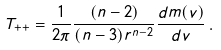Convert formula to latex. <formula><loc_0><loc_0><loc_500><loc_500>T _ { + + } = \frac { 1 } { 2 \pi } \frac { ( n - 2 ) } { ( n - 3 ) r ^ { n - 2 } } \frac { d m ( v ) } { d v } \, .</formula> 